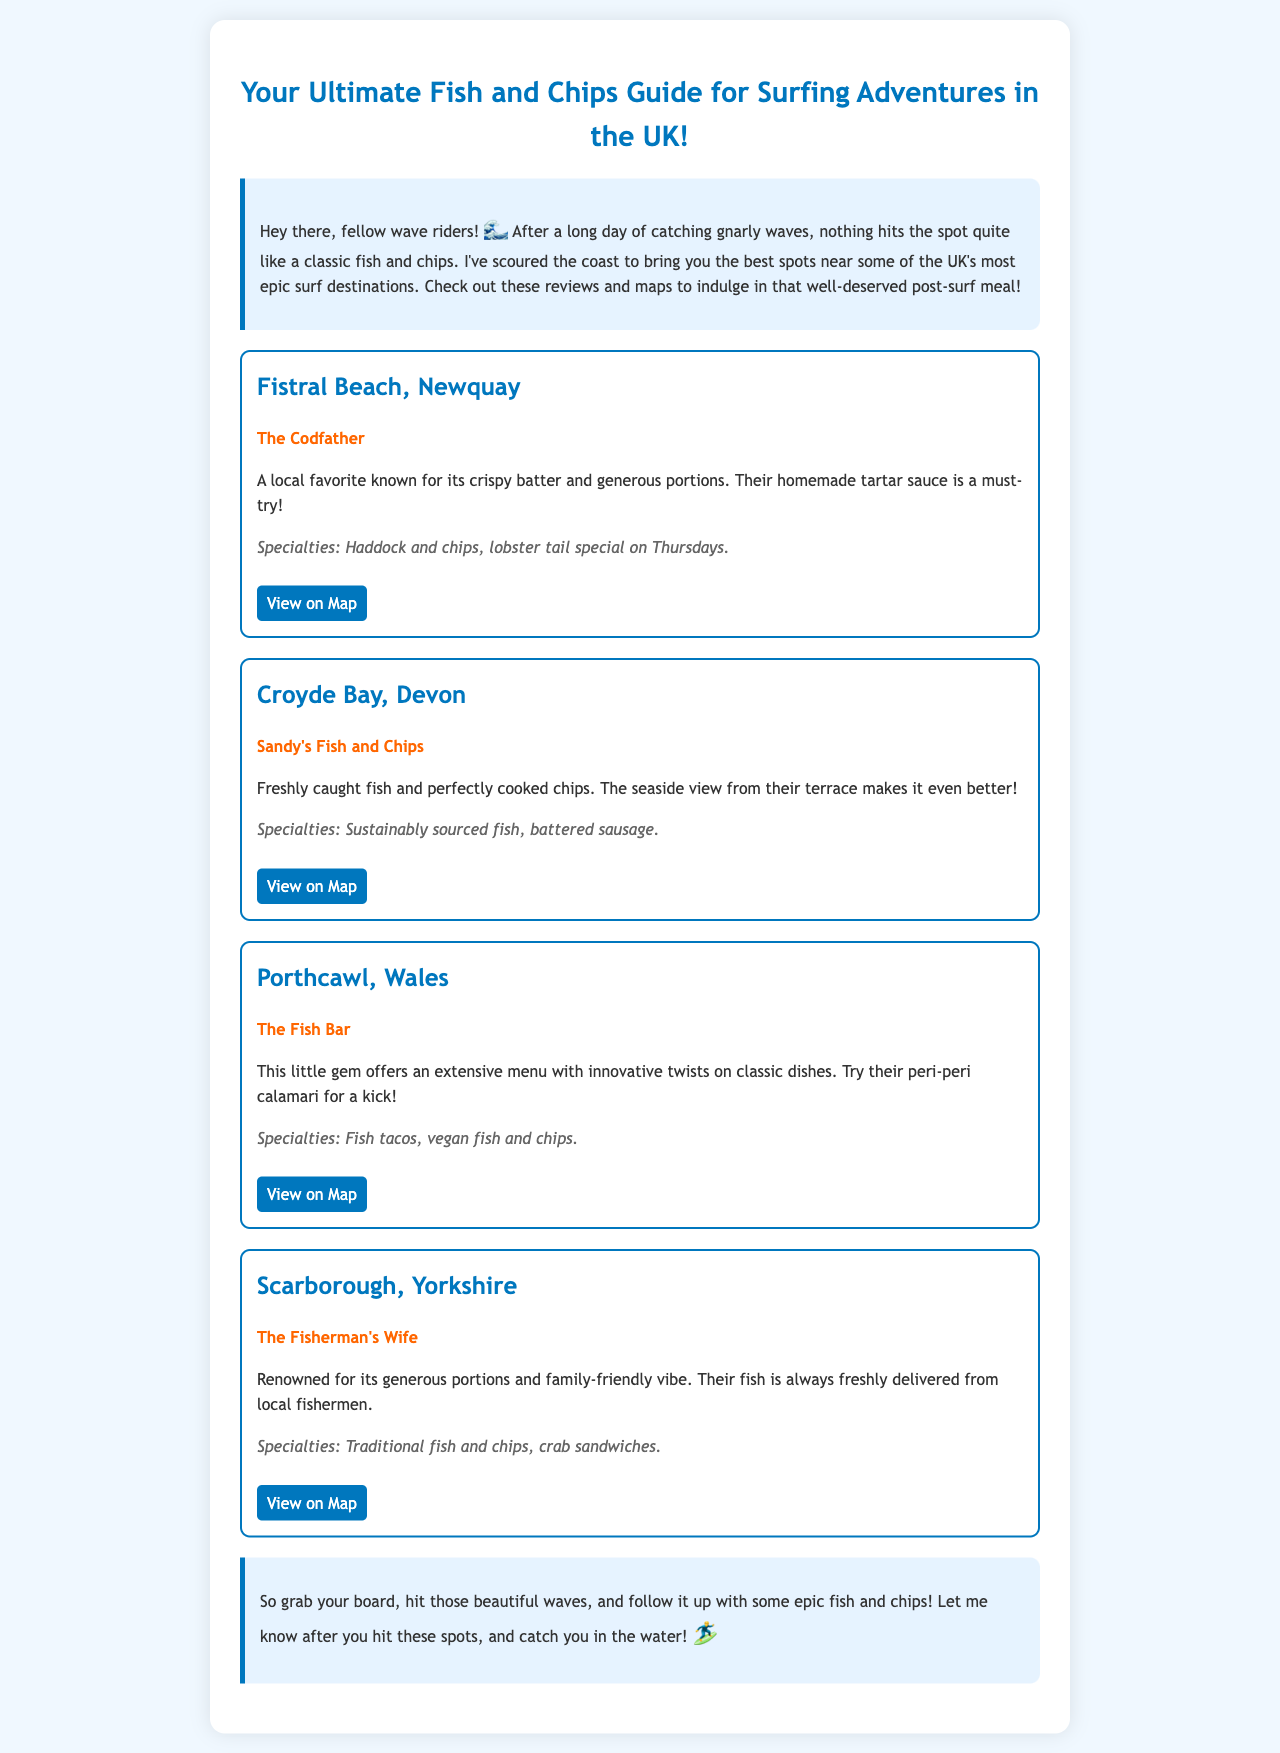What is the title of the guide? The title of the guide as indicated in the document is in the header section.
Answer: Your Ultimate Fish and Chips Guide for Surfing Adventures in the UK! What is the first shop listed? The first destination in the document features "The Codfather" as the shop.
Answer: The Codfather Which beach is associated with Sandy's Fish and Chips? The document specifies that Sandy's Fish and Chips is found near Croyde Bay.
Answer: Croyde Bay What is a specialty offered at The Fish Bar? The document lists "fish tacos" as one of the specialties at The Fish Bar.
Answer: Fish tacos How many destinations are mentioned in the guide? Counting the number of unique destinations in the document provides the total.
Answer: Four What is the special on Thursdays at The Codfather? The document specifically mentions a "lobster tail special" available on Thursdays.
Answer: Lobster tail special on Thursdays What color is used for the headings in the document? The color for the headings has been defined in the style section of the document.
Answer: Blue Which map link corresponds to The Fisherman's Wife? The map link provided directly after The Fisherman's Wife section leads to Google Maps for that shop.
Answer: https://goo.gl/maps/oFgXpH8zF9D2 